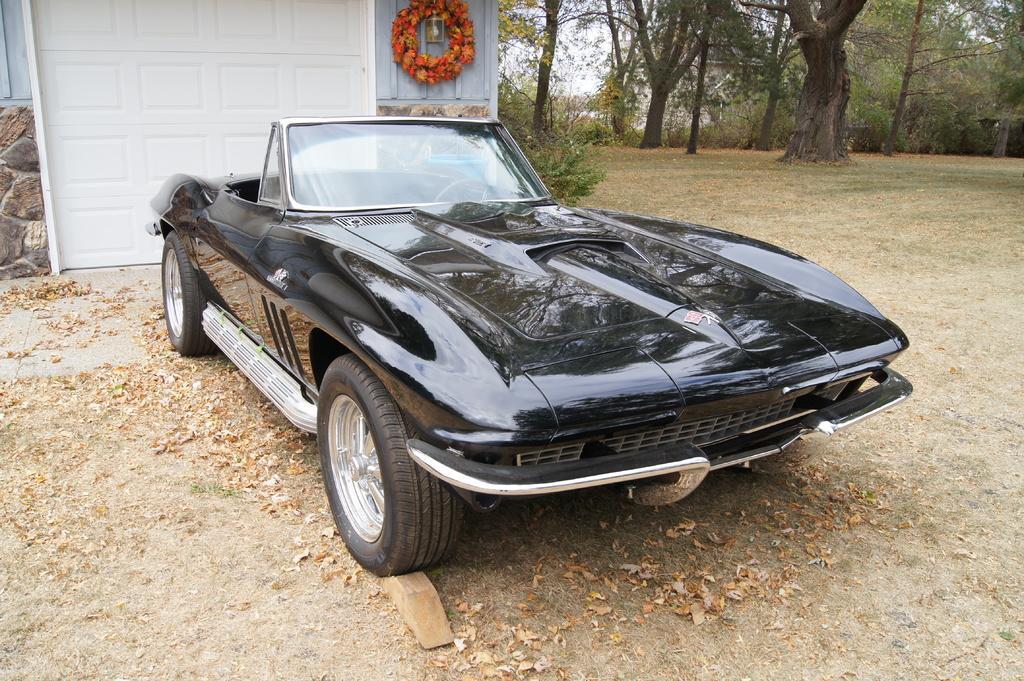Describe this image in one or two sentences. In the picture we can see a grass surface on it, we can see some dried leaves and a car which is black in color with an open top and behind it, we can see a white color wall substance inside it, we can see some floor decoration on the wall and in the background we can see plants, trees and sky. 